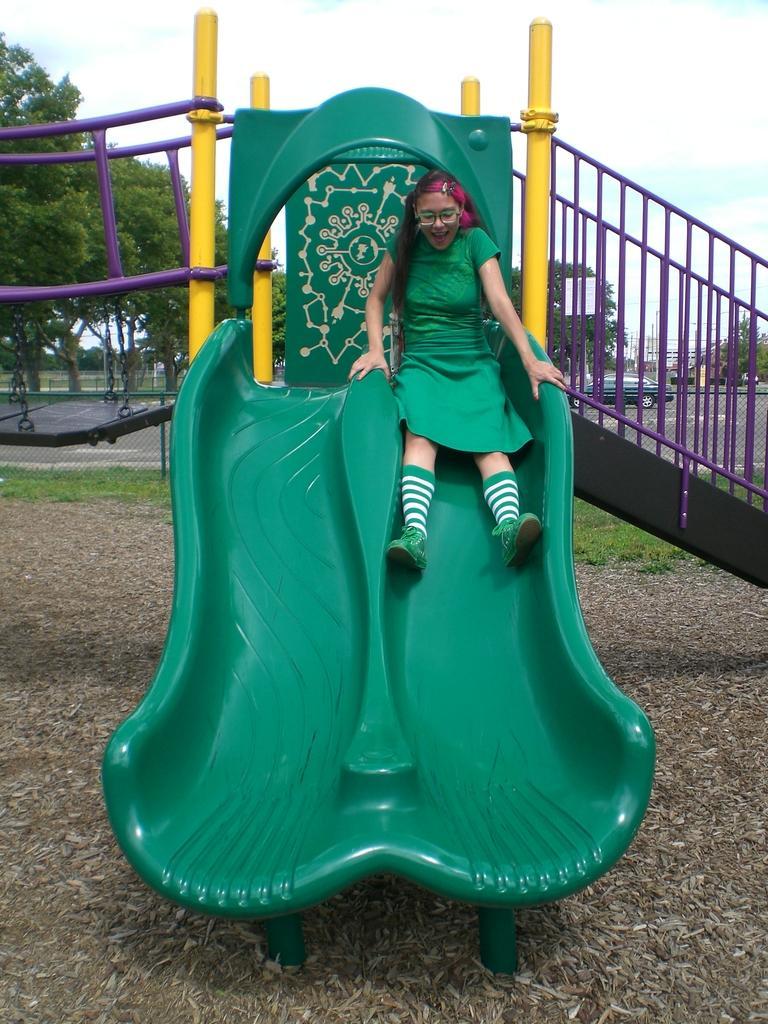In one or two sentences, can you explain what this image depicts? In this image, we can see a girl is sliding on a slider. and smiling. She wore glasses and hair band. Here we can see rods, chains, trees, road, vehicle, grass. Background there is a sky. At the bottom of the image, we can see the ground. 